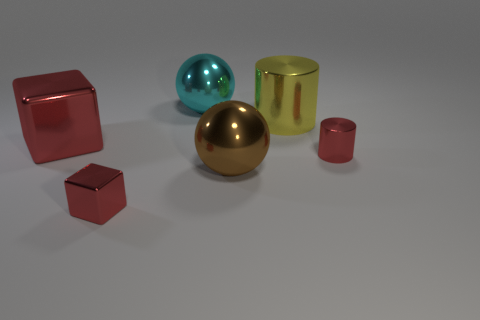What shape is the big object that is the same color as the tiny cylinder?
Keep it short and to the point. Cube. Are there any other things of the same color as the small cube?
Your response must be concise. Yes. There is a cyan shiny object that is the same size as the brown metal object; what shape is it?
Provide a short and direct response. Sphere. How many metal things are both behind the small block and in front of the large yellow metal thing?
Offer a terse response. 3. Are there fewer big yellow cylinders that are in front of the small cube than large yellow cylinders?
Offer a very short reply. Yes. Is there a metal block that has the same size as the yellow metal cylinder?
Provide a short and direct response. Yes. What color is the big cylinder that is made of the same material as the small cylinder?
Offer a very short reply. Yellow. There is a thing left of the tiny cube; what number of large red objects are behind it?
Ensure brevity in your answer.  0. There is a red object that is both on the right side of the large metal block and to the left of the tiny red shiny cylinder; what is it made of?
Ensure brevity in your answer.  Metal. Do the big cyan thing behind the small metal block and the yellow metal object have the same shape?
Give a very brief answer. No. 